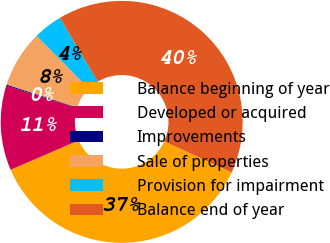<chart> <loc_0><loc_0><loc_500><loc_500><pie_chart><fcel>Balance beginning of year<fcel>Developed or acquired<fcel>Improvements<fcel>Sale of properties<fcel>Provision for impairment<fcel>Balance end of year<nl><fcel>36.67%<fcel>11.32%<fcel>0.15%<fcel>7.6%<fcel>3.87%<fcel>40.39%<nl></chart> 